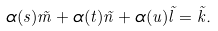Convert formula to latex. <formula><loc_0><loc_0><loc_500><loc_500>\alpha ( s ) \tilde { m } + \alpha ( t ) \tilde { n } + \alpha ( u ) \tilde { l } = \tilde { k } .</formula> 